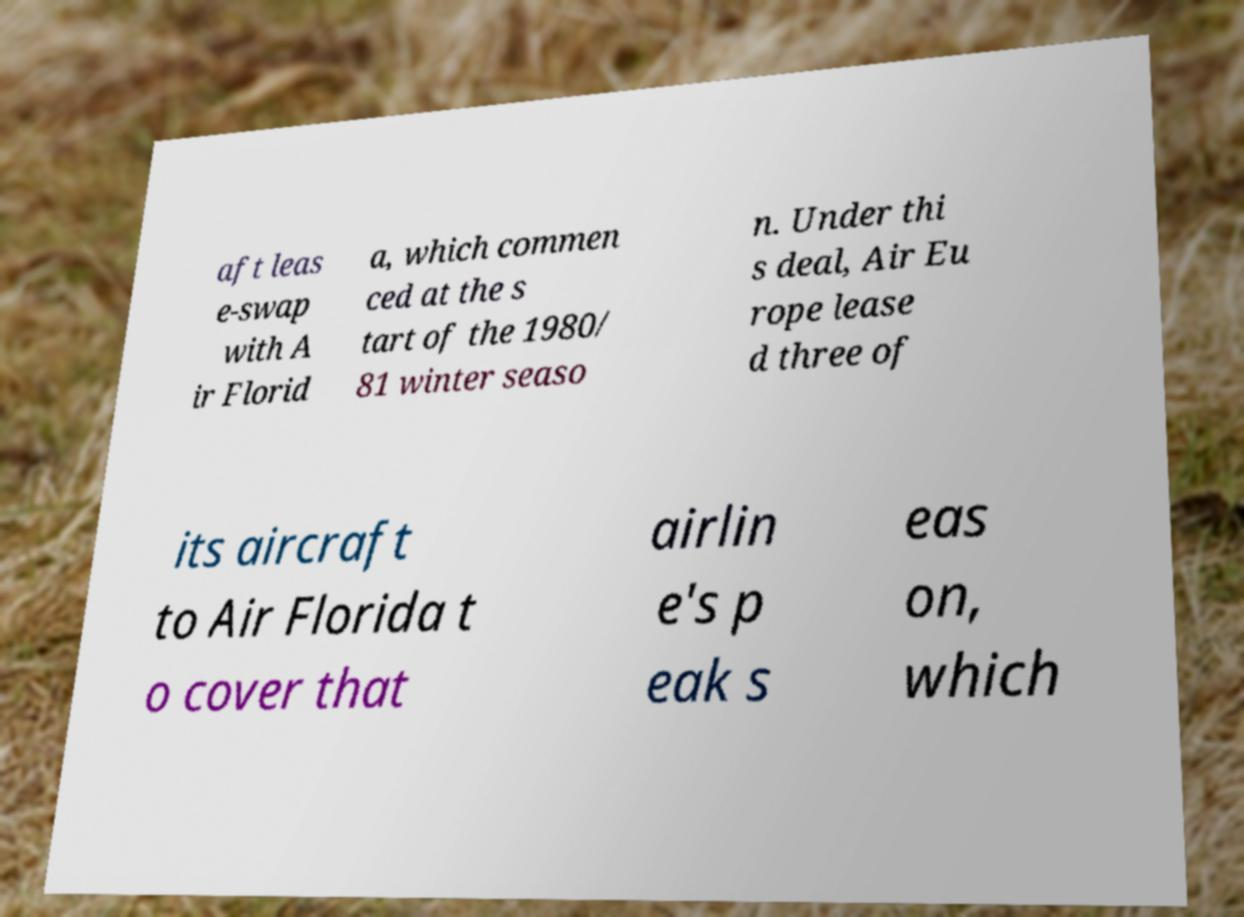What messages or text are displayed in this image? I need them in a readable, typed format. aft leas e-swap with A ir Florid a, which commen ced at the s tart of the 1980/ 81 winter seaso n. Under thi s deal, Air Eu rope lease d three of its aircraft to Air Florida t o cover that airlin e's p eak s eas on, which 